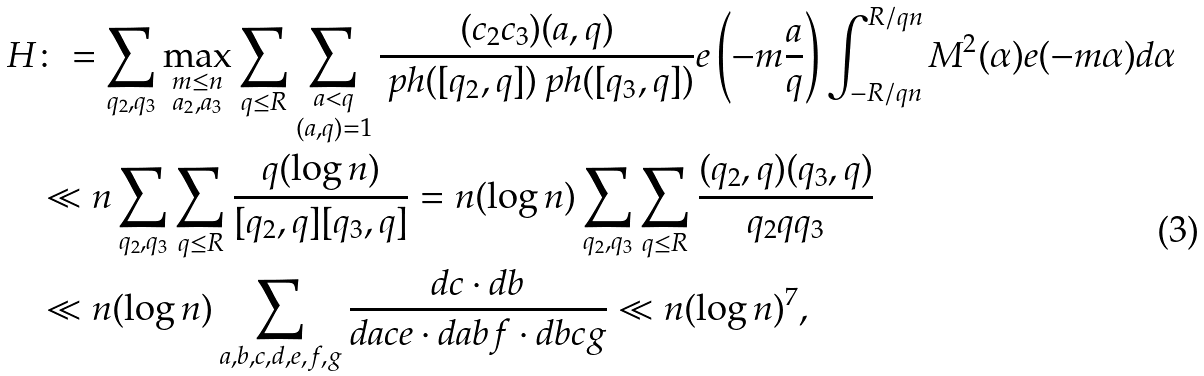Convert formula to latex. <formula><loc_0><loc_0><loc_500><loc_500>H & \colon = \sum _ { q _ { 2 } , q _ { 3 } } \max _ { \substack { m \leq n \\ a _ { 2 } , a _ { 3 } } } \sum _ { q \leq R } \sum _ { \substack { a < q \\ ( a , q ) = 1 } } \frac { ( c _ { 2 } c _ { 3 } ) ( a , q ) } { \ p h ( [ q _ { 2 } , q ] ) \ p h ( [ q _ { 3 } , q ] ) } e \left ( - m \frac { a } { q } \right ) \int _ { - R / q n } ^ { R / q n } M ^ { 2 } ( \alpha ) e ( - m \alpha ) d \alpha \\ & \ll n \sum _ { q _ { 2 } , q _ { 3 } } \sum _ { q \leq R } \frac { q ( \log n ) } { [ q _ { 2 } , q ] [ q _ { 3 } , q ] } = n ( \log n ) \sum _ { q _ { 2 } , q _ { 3 } } \sum _ { q \leq R } \frac { ( q _ { 2 } , q ) ( q _ { 3 } , q ) } { q _ { 2 } q q _ { 3 } } \\ & \ll n ( \log n ) \sum _ { a , b , c , d , e , f , g } \frac { d c \cdot d b } { d a c e \cdot d a b f \cdot d b c g } \ll n ( \log n ) ^ { 7 } ,</formula> 